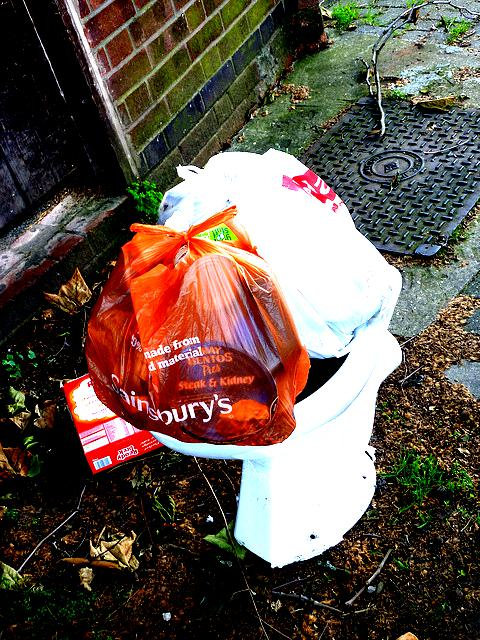Is the image of acceptable quality? Yes, the image is of acceptable quality as it is clear and the subject matter is easily identifiable, allowing for a detailed examination and discussion of its contents. 